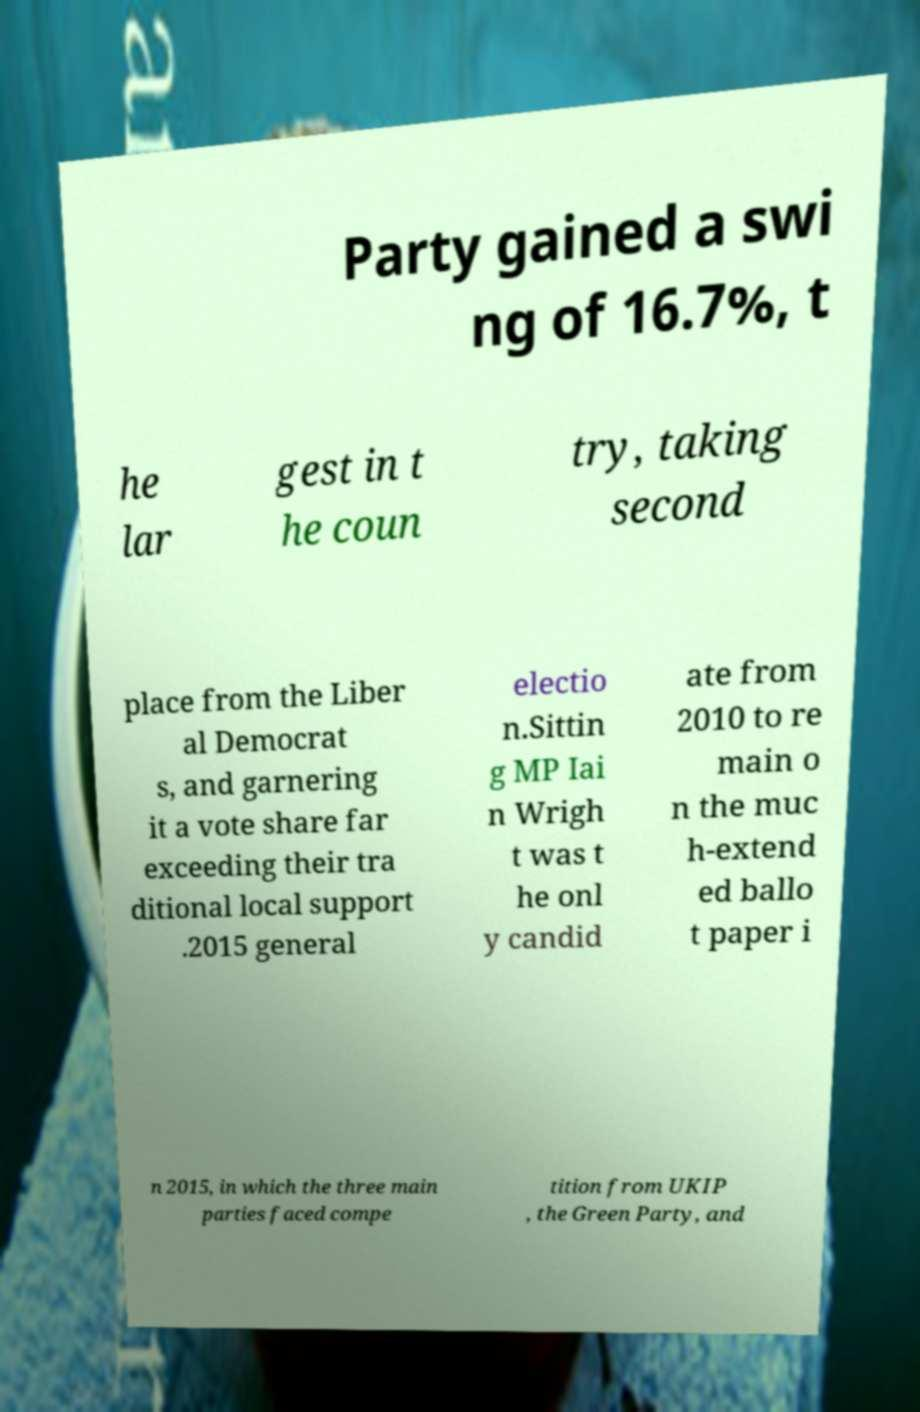I need the written content from this picture converted into text. Can you do that? Party gained a swi ng of 16.7%, t he lar gest in t he coun try, taking second place from the Liber al Democrat s, and garnering it a vote share far exceeding their tra ditional local support .2015 general electio n.Sittin g MP Iai n Wrigh t was t he onl y candid ate from 2010 to re main o n the muc h-extend ed ballo t paper i n 2015, in which the three main parties faced compe tition from UKIP , the Green Party, and 